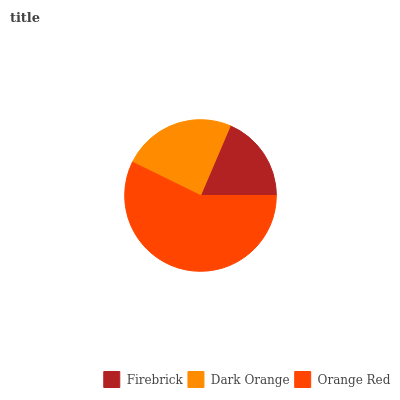Is Firebrick the minimum?
Answer yes or no. Yes. Is Orange Red the maximum?
Answer yes or no. Yes. Is Dark Orange the minimum?
Answer yes or no. No. Is Dark Orange the maximum?
Answer yes or no. No. Is Dark Orange greater than Firebrick?
Answer yes or no. Yes. Is Firebrick less than Dark Orange?
Answer yes or no. Yes. Is Firebrick greater than Dark Orange?
Answer yes or no. No. Is Dark Orange less than Firebrick?
Answer yes or no. No. Is Dark Orange the high median?
Answer yes or no. Yes. Is Dark Orange the low median?
Answer yes or no. Yes. Is Orange Red the high median?
Answer yes or no. No. Is Orange Red the low median?
Answer yes or no. No. 